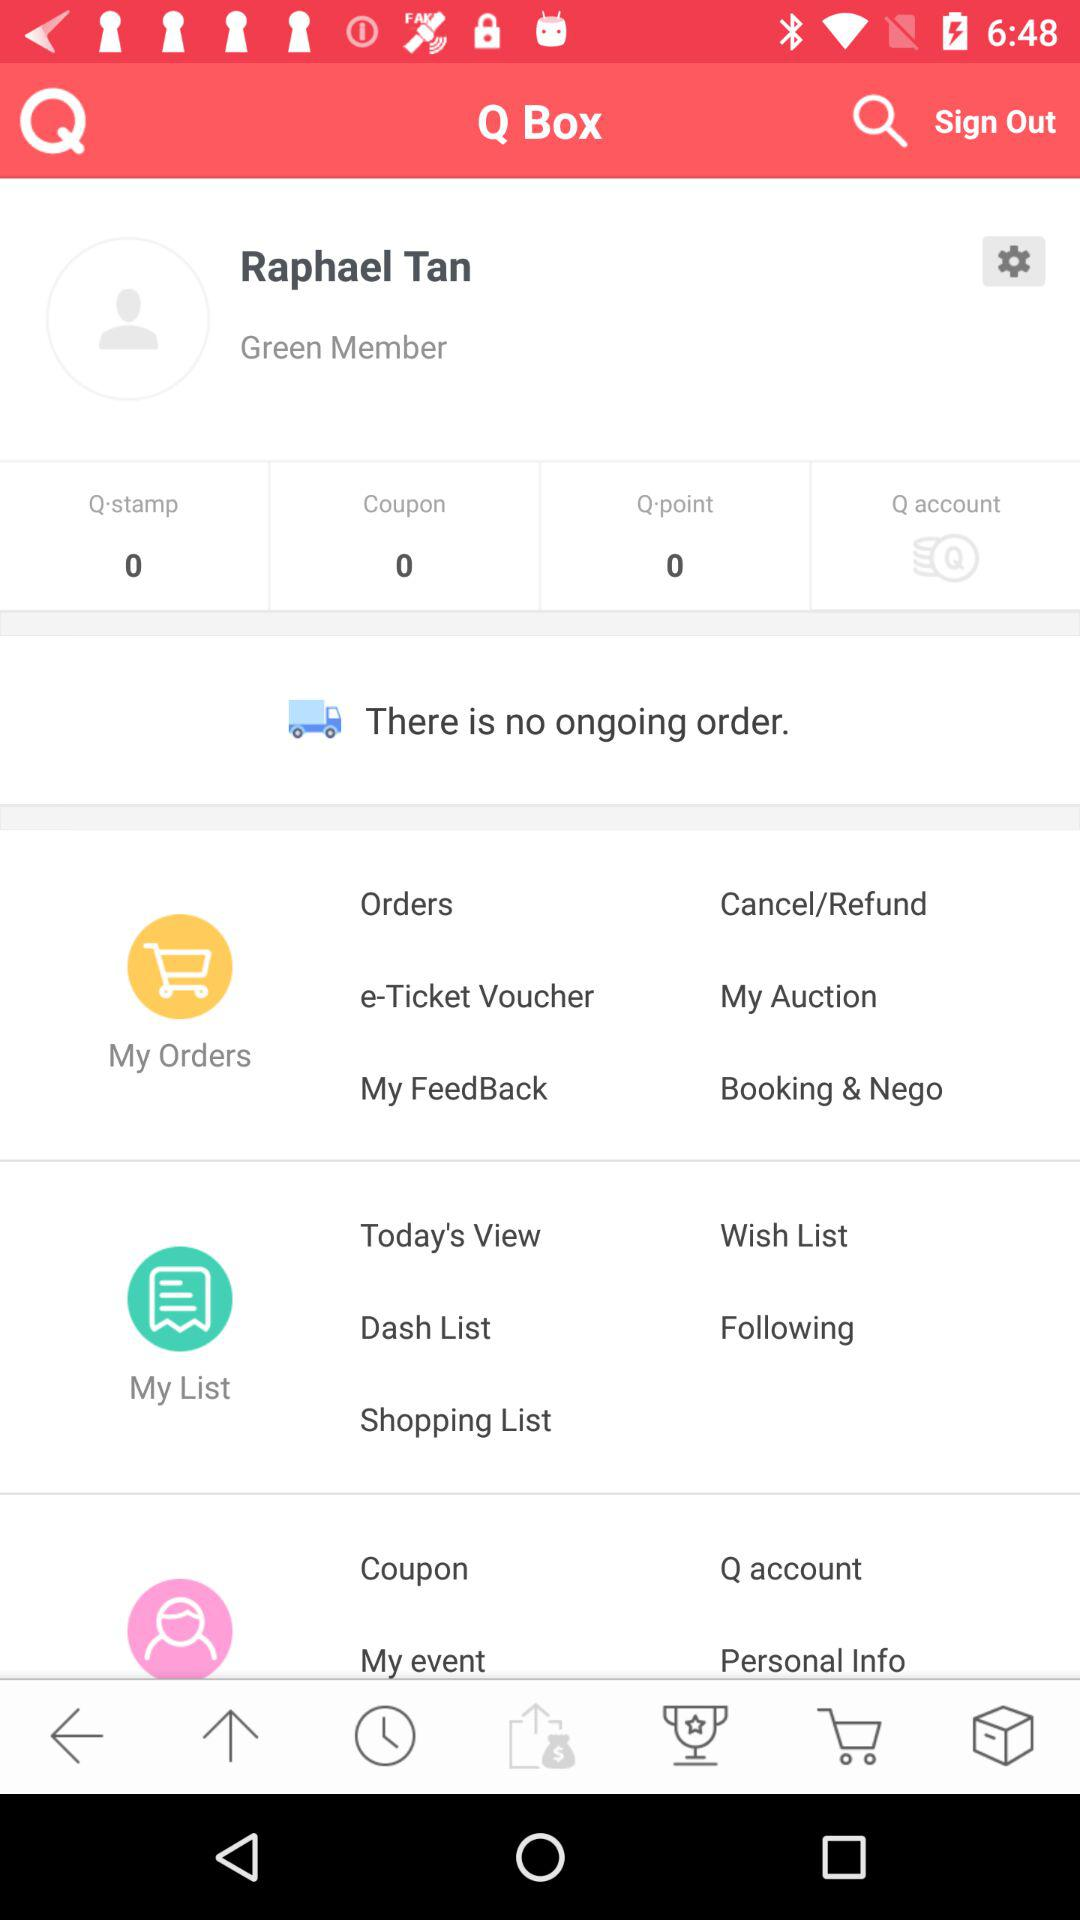What's the count of the coupon? The count of the coupon is 0. 